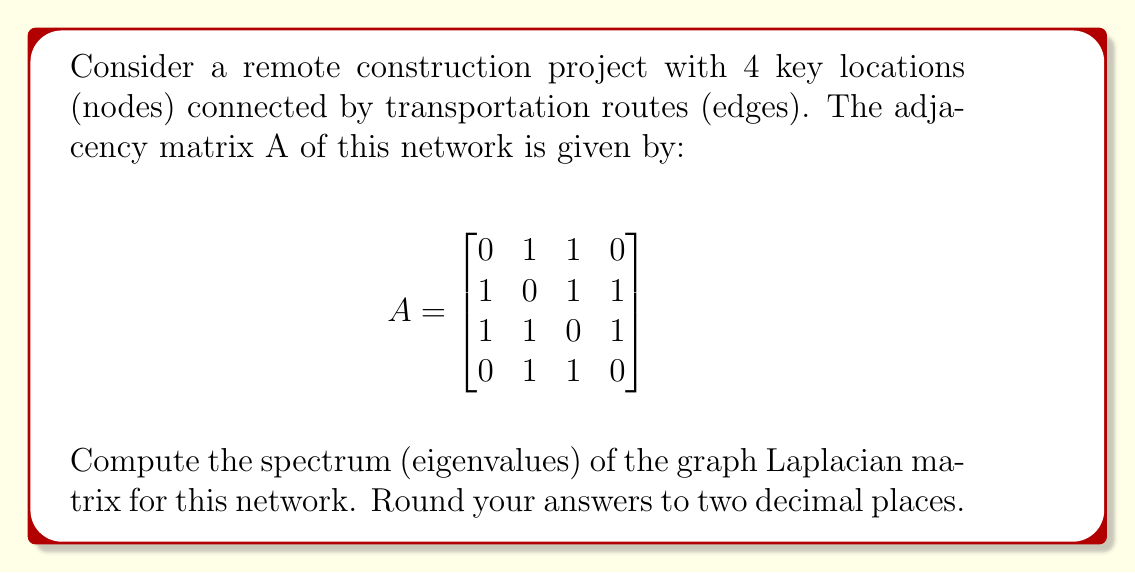Give your solution to this math problem. To solve this problem, we'll follow these steps:

1) First, we need to calculate the degree matrix D. The degree of each node is the sum of its connections:
   Node 1: 2, Node 2: 3, Node 3: 3, Node 4: 2
   
   $$D = \begin{bmatrix}
   2 & 0 & 0 & 0 \\
   0 & 3 & 0 & 0 \\
   0 & 0 & 3 & 0 \\
   0 & 0 & 0 & 2
   \end{bmatrix}$$

2) The graph Laplacian L is defined as L = D - A:

   $$L = D - A = \begin{bmatrix}
   2 & 0 & 0 & 0 \\
   0 & 3 & 0 & 0 \\
   0 & 0 & 3 & 0 \\
   0 & 0 & 0 & 2
   \end{bmatrix} - \begin{bmatrix}
   0 & 1 & 1 & 0 \\
   1 & 0 & 1 & 1 \\
   1 & 1 & 0 & 1 \\
   0 & 1 & 1 & 0
   \end{bmatrix} = \begin{bmatrix}
   2 & -1 & -1 & 0 \\
   -1 & 3 & -1 & -1 \\
   -1 & -1 & 3 & -1 \\
   0 & -1 & -1 & 2
   \end{bmatrix}$$

3) To find the eigenvalues, we need to solve the characteristic equation:
   $det(L - \lambda I) = 0$

4) Expanding this determinant:
   $(\lambda-2)(\lambda-3)(\lambda-3)(\lambda-2) - (\lambda-2)(\lambda-3) - (\lambda-2)(\lambda-3) - (\lambda-3)(\lambda-3) = 0$

5) Simplifying:
   $\lambda^4 - 10\lambda^3 + 33\lambda^2 - 36\lambda = 0$

6) Factoring out $\lambda$:
   $\lambda(\lambda^3 - 10\lambda^2 + 33\lambda - 36) = 0$

7) Solving this equation, we get the eigenvalues:
   $\lambda_1 = 0$
   $\lambda_2 = 2$
   $\lambda_3 = 4$
   $\lambda_4 = 4$

8) Rounding to two decimal places:
   $\lambda_1 = 0.00$
   $\lambda_2 = 2.00$
   $\lambda_3 = 4.00$
   $\lambda_4 = 4.00$
Answer: $\{0.00, 2.00, 4.00, 4.00\}$ 